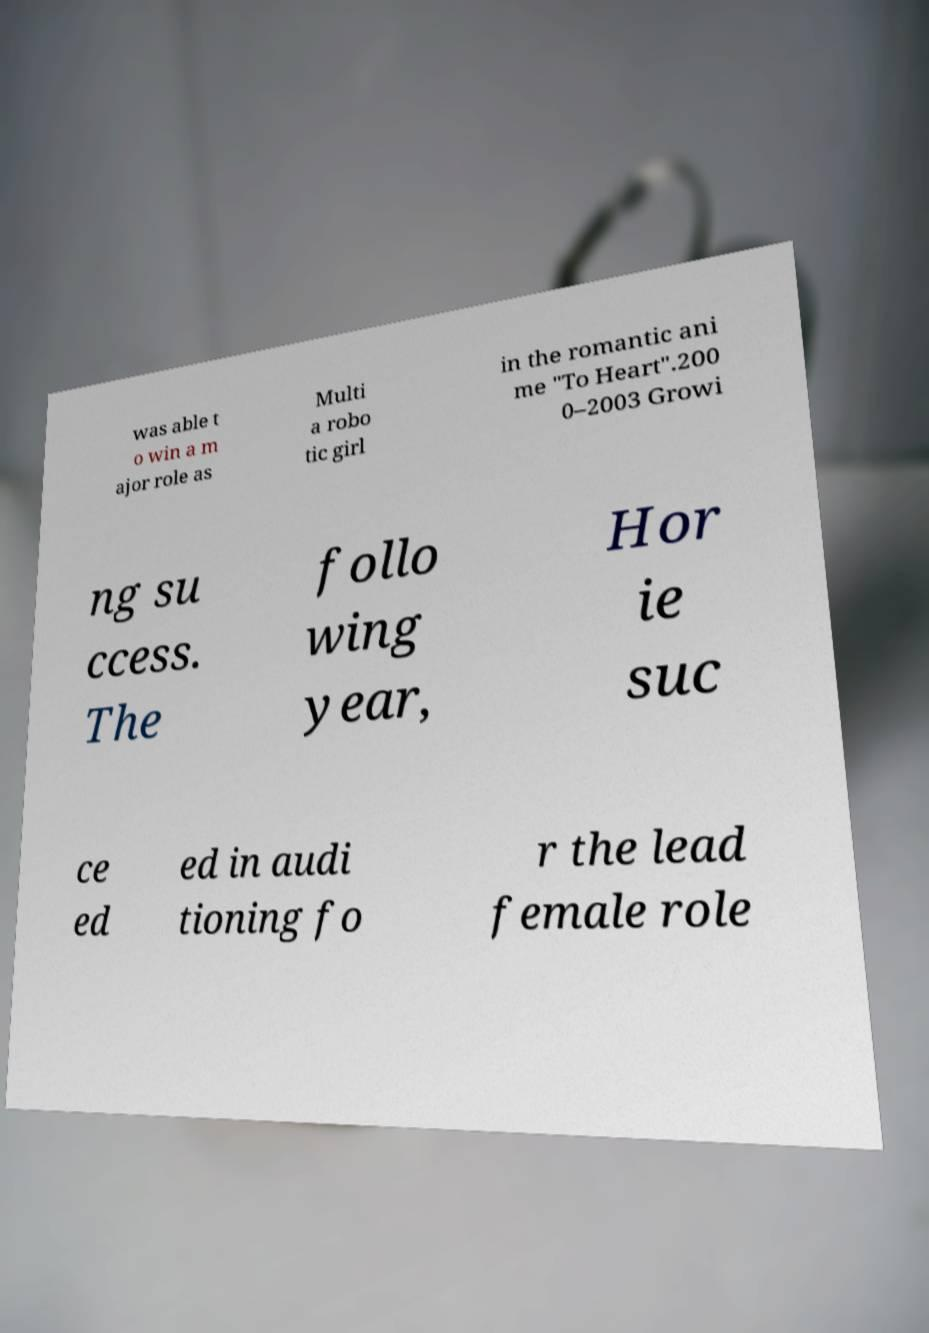I need the written content from this picture converted into text. Can you do that? was able t o win a m ajor role as Multi a robo tic girl in the romantic ani me "To Heart".200 0–2003 Growi ng su ccess. The follo wing year, Hor ie suc ce ed ed in audi tioning fo r the lead female role 